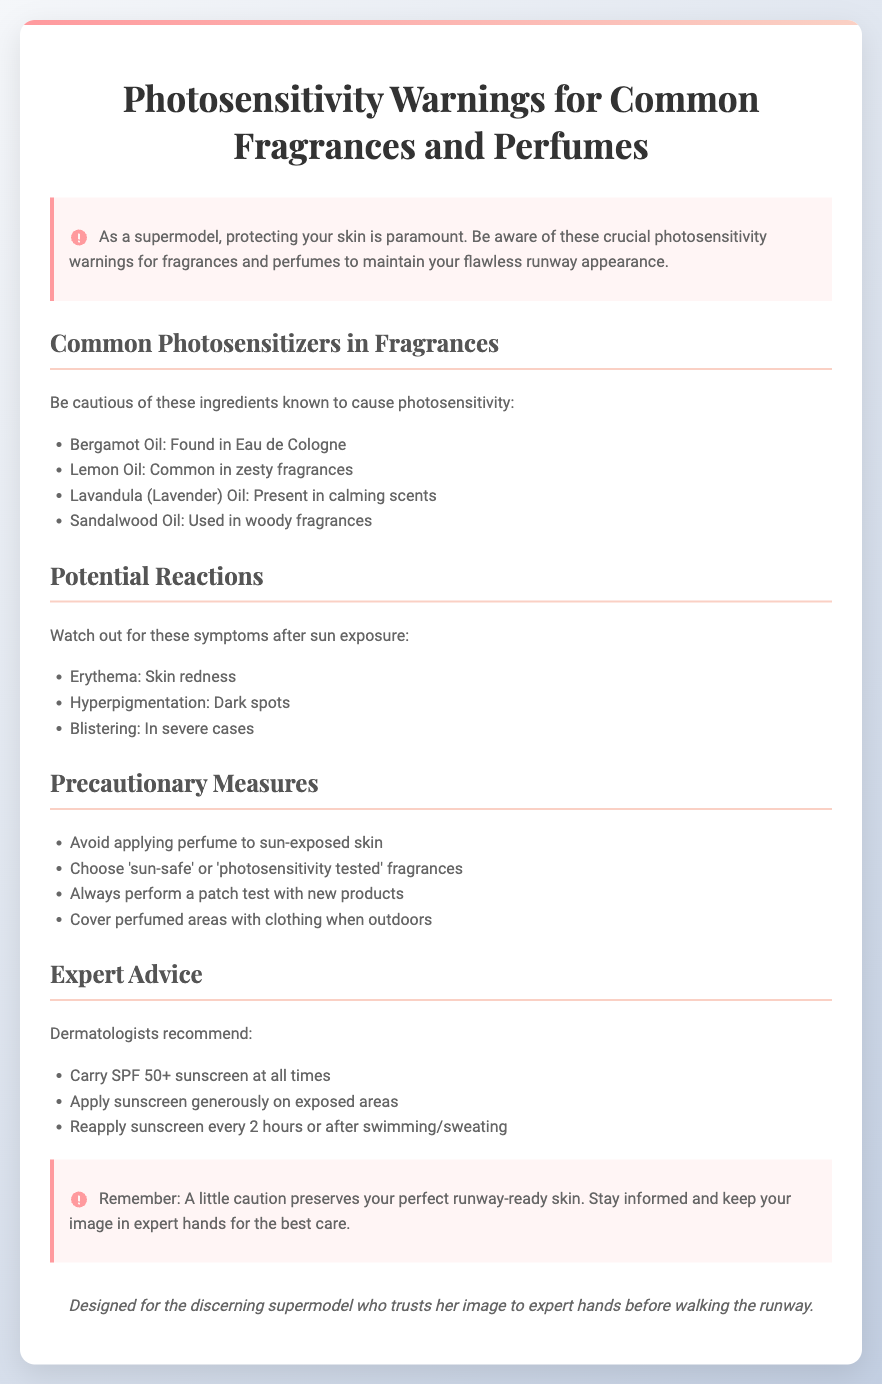What is the title of the document? The title is given prominently at the top of the document, stating the focus of the warnings.
Answer: Photosensitivity Warnings for Common Fragrances and Perfumes What essential precaution is advised regarding perfume application? The document emphasizes the importance of certain precautionary measures to safeguard skin health, specifically related to sun exposure.
Answer: Avoid applying perfume to sun-exposed skin Which oil is found in Eau de Cologne? The document lists specific ingredients known for causing photosensitivity, including their common uses in fragrances.
Answer: Bergamot Oil What are symptoms to watch for after sun exposure? The document describes specific potential reactions that can occur after exposure to the sun when using certain fragrances.
Answer: Erythema What SPF level is recommended to carry at all times? The document provides expert advice regarding sun protection, highlighting the importance of sunscreen.
Answer: SPF 50+ What type of fragrances should be chosen to ensure safety? The document suggests certain types of fragrances that are safer for those concerned about photosensitivity.
Answer: 'Sun-safe' or 'photosensitivity tested' fragrances What color is used for the warning label background? The document describes the stylistic choices made for the layout and appearance of the label to make it stand out effectively.
Answer: White What does the document emphasize about skin protection? The opening statement of the document highlights the critical importance of skin protection, especially for someone in the modeling industry.
Answer: Protecting your skin is paramount 